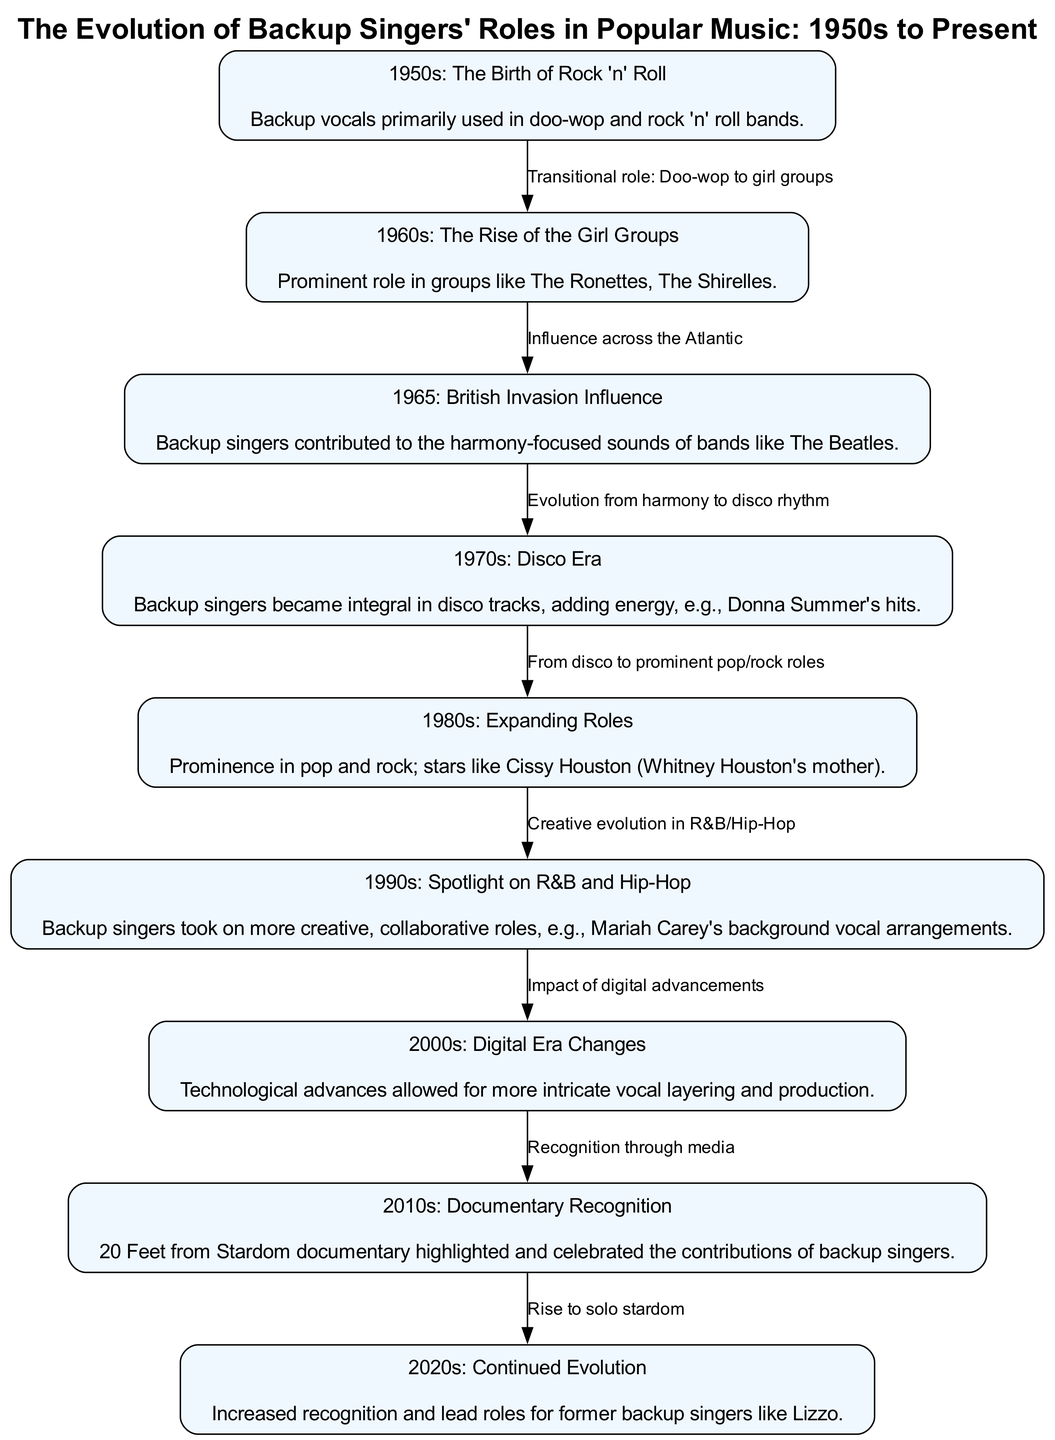What decade saw the birth of Rock 'n' Roll? The diagram specifies the 1950s as the decade when backup vocals were primarily used in doo-wop and rock 'n' roll bands, marking the birth of Rock 'n' Roll.
Answer: 1950s Which notable girl group emerged in the 1960s? The diagram lists The Ronettes and The Shirelles as examples of groups that represented the prominent role of backup singers during the 1960s, indicating their emergence as significant contributors in that era.
Answer: The Ronettes What was a key influence on backup singers in 1965? According to the diagram, the British Invasion influenced the role of backup singers, contributing to the harmony-focused sounds of bands like The Beatles during that time.
Answer: British Invasion How did the role of backup singers shift in the 1970s? The diagram states that during the 1970s in the Disco Era, backup singers became integral in disco tracks, adding energy to music, which signifies a shift in their role.
Answer: Integral in disco tracks What major change occurred for backup singers in the 1990s? The diagram describes that in the 1990s, backup singers took on more creative, collaborative roles, evidenced by Mariah Carey's background vocal arrangements, indicating a significant change in their contributions to music.
Answer: Creative, collaborative roles What document highlighted the contributions of backup singers in the 2010s? The diagram mentions the documentary "20 Feet from Stardom," which celebrated and recognized the contributions of backup singers, thus illustrating a moment of acknowledgment in that decade.
Answer: 20 Feet from Stardom Which decade marks the continued evolution and recognition of backup singers? The diagram indicates the 2020s as the time when there was increased recognition and lead roles for former backup singers, such as Lizzo, marking their continued evolution in the industry.
Answer: 2020s What connects the 1980s and 1990s in terms of backup singers? The diagram illustrates a transition from the expanding roles of backup singers in the 1980s to their creative evolution in R&B and Hip-Hop in the 1990s, highlighting the connection between these two decades.
Answer: Creative evolution in R&B/Hip-Hop How many nodes are present in the diagram? By counting the nodes representing different decades, the diagram specifies eight nodes related to the evolution of backup singers from the 1950s through the 2020s.
Answer: Eight nodes 